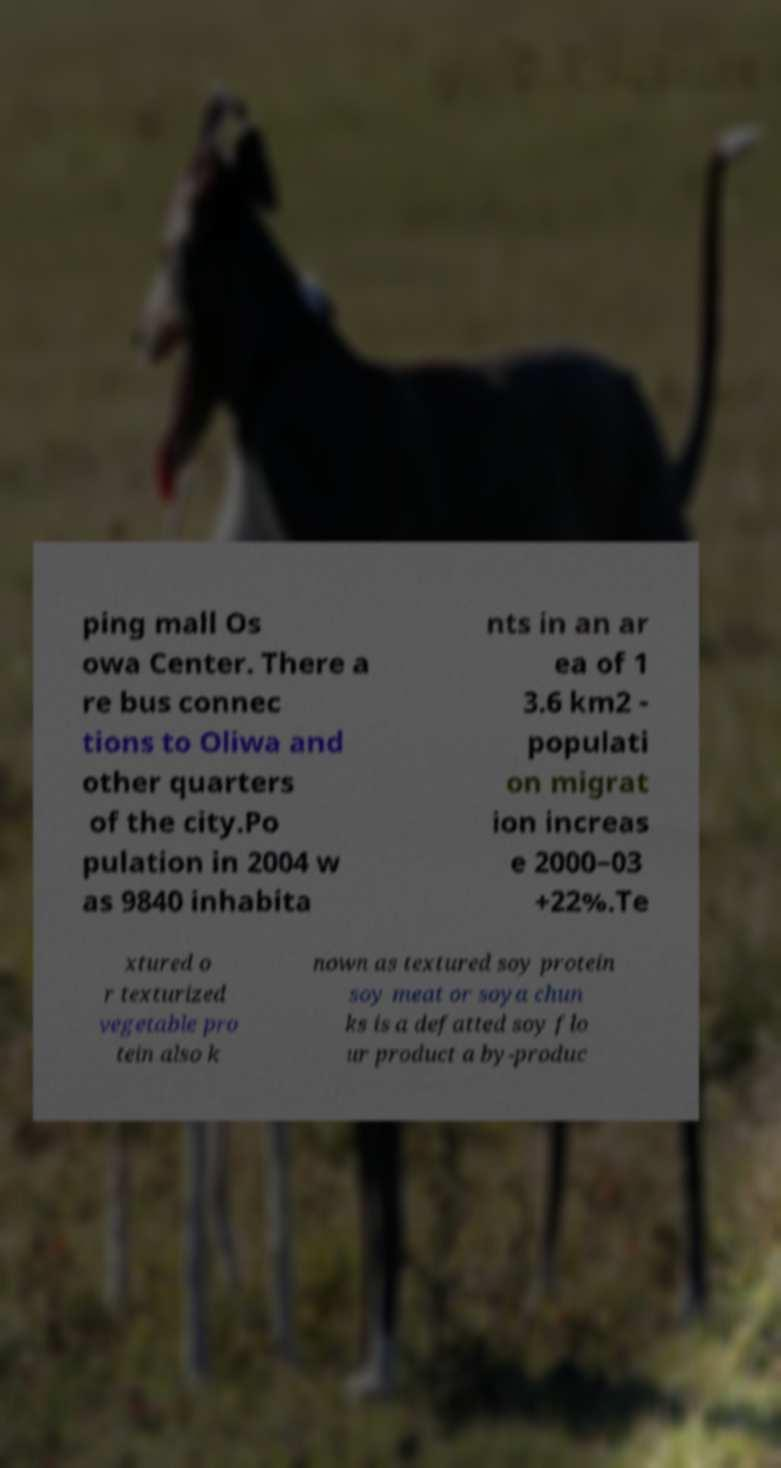Could you assist in decoding the text presented in this image and type it out clearly? ping mall Os owa Center. There a re bus connec tions to Oliwa and other quarters of the city.Po pulation in 2004 w as 9840 inhabita nts in an ar ea of 1 3.6 km2 - populati on migrat ion increas e 2000–03 +22%.Te xtured o r texturized vegetable pro tein also k nown as textured soy protein soy meat or soya chun ks is a defatted soy flo ur product a by-produc 